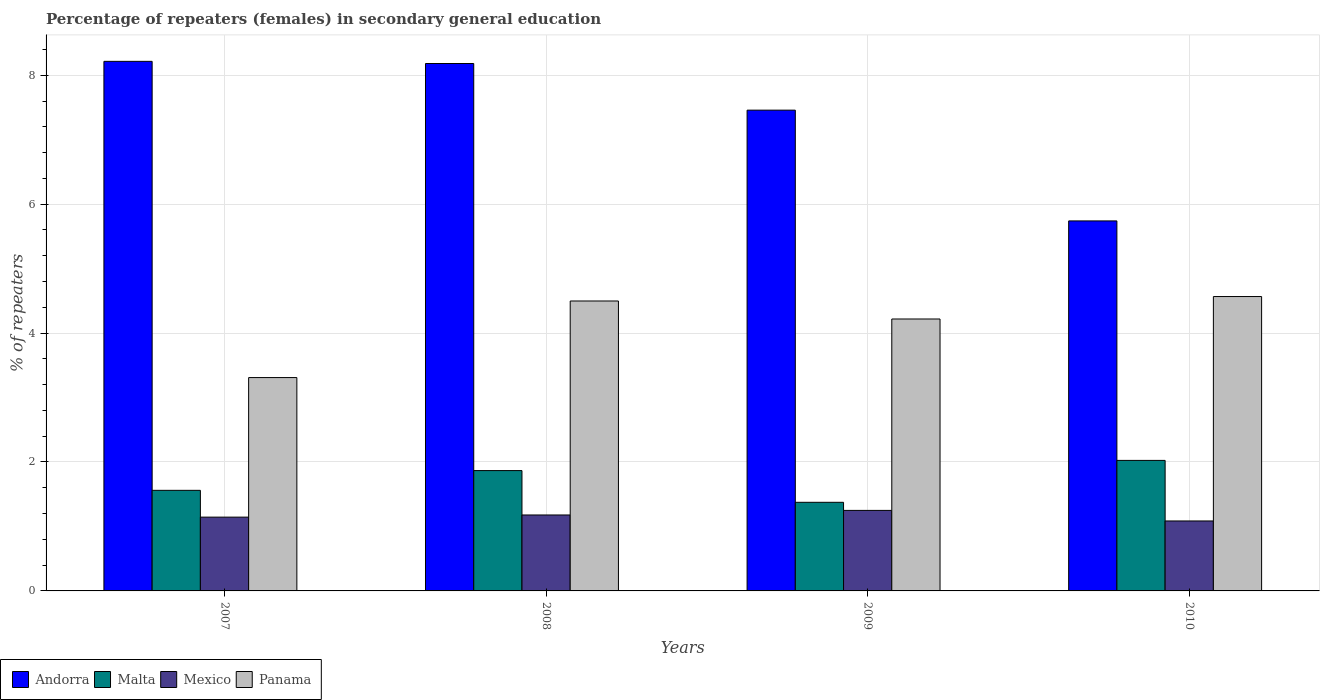How many different coloured bars are there?
Keep it short and to the point. 4. Are the number of bars per tick equal to the number of legend labels?
Your answer should be compact. Yes. In how many cases, is the number of bars for a given year not equal to the number of legend labels?
Your answer should be compact. 0. What is the percentage of female repeaters in Panama in 2007?
Offer a very short reply. 3.31. Across all years, what is the maximum percentage of female repeaters in Mexico?
Provide a short and direct response. 1.25. Across all years, what is the minimum percentage of female repeaters in Mexico?
Offer a very short reply. 1.09. In which year was the percentage of female repeaters in Malta maximum?
Provide a short and direct response. 2010. In which year was the percentage of female repeaters in Mexico minimum?
Your response must be concise. 2010. What is the total percentage of female repeaters in Andorra in the graph?
Provide a short and direct response. 29.6. What is the difference between the percentage of female repeaters in Andorra in 2008 and that in 2010?
Give a very brief answer. 2.44. What is the difference between the percentage of female repeaters in Andorra in 2007 and the percentage of female repeaters in Mexico in 2009?
Your answer should be very brief. 6.97. What is the average percentage of female repeaters in Andorra per year?
Offer a very short reply. 7.4. In the year 2010, what is the difference between the percentage of female repeaters in Malta and percentage of female repeaters in Panama?
Provide a short and direct response. -2.54. In how many years, is the percentage of female repeaters in Mexico greater than 2 %?
Your response must be concise. 0. What is the ratio of the percentage of female repeaters in Malta in 2007 to that in 2010?
Make the answer very short. 0.77. Is the percentage of female repeaters in Mexico in 2008 less than that in 2010?
Provide a succinct answer. No. Is the difference between the percentage of female repeaters in Malta in 2007 and 2008 greater than the difference between the percentage of female repeaters in Panama in 2007 and 2008?
Your answer should be compact. Yes. What is the difference between the highest and the second highest percentage of female repeaters in Malta?
Make the answer very short. 0.16. What is the difference between the highest and the lowest percentage of female repeaters in Panama?
Your response must be concise. 1.26. In how many years, is the percentage of female repeaters in Andorra greater than the average percentage of female repeaters in Andorra taken over all years?
Your response must be concise. 3. Is the sum of the percentage of female repeaters in Panama in 2008 and 2010 greater than the maximum percentage of female repeaters in Andorra across all years?
Keep it short and to the point. Yes. Is it the case that in every year, the sum of the percentage of female repeaters in Panama and percentage of female repeaters in Mexico is greater than the sum of percentage of female repeaters in Andorra and percentage of female repeaters in Malta?
Your response must be concise. No. What does the 3rd bar from the left in 2008 represents?
Provide a succinct answer. Mexico. What does the 3rd bar from the right in 2007 represents?
Your response must be concise. Malta. Is it the case that in every year, the sum of the percentage of female repeaters in Mexico and percentage of female repeaters in Malta is greater than the percentage of female repeaters in Panama?
Provide a succinct answer. No. How many bars are there?
Provide a short and direct response. 16. Are all the bars in the graph horizontal?
Offer a terse response. No. How many years are there in the graph?
Offer a terse response. 4. What is the difference between two consecutive major ticks on the Y-axis?
Provide a succinct answer. 2. Are the values on the major ticks of Y-axis written in scientific E-notation?
Offer a very short reply. No. Where does the legend appear in the graph?
Ensure brevity in your answer.  Bottom left. What is the title of the graph?
Offer a terse response. Percentage of repeaters (females) in secondary general education. What is the label or title of the X-axis?
Give a very brief answer. Years. What is the label or title of the Y-axis?
Your answer should be compact. % of repeaters. What is the % of repeaters of Andorra in 2007?
Offer a very short reply. 8.22. What is the % of repeaters in Malta in 2007?
Provide a short and direct response. 1.56. What is the % of repeaters in Mexico in 2007?
Provide a short and direct response. 1.14. What is the % of repeaters in Panama in 2007?
Keep it short and to the point. 3.31. What is the % of repeaters of Andorra in 2008?
Provide a short and direct response. 8.18. What is the % of repeaters of Malta in 2008?
Your response must be concise. 1.87. What is the % of repeaters in Mexico in 2008?
Provide a short and direct response. 1.18. What is the % of repeaters of Panama in 2008?
Your answer should be compact. 4.5. What is the % of repeaters of Andorra in 2009?
Keep it short and to the point. 7.46. What is the % of repeaters in Malta in 2009?
Offer a very short reply. 1.37. What is the % of repeaters of Mexico in 2009?
Make the answer very short. 1.25. What is the % of repeaters of Panama in 2009?
Give a very brief answer. 4.22. What is the % of repeaters in Andorra in 2010?
Provide a short and direct response. 5.74. What is the % of repeaters in Malta in 2010?
Your response must be concise. 2.02. What is the % of repeaters in Mexico in 2010?
Make the answer very short. 1.09. What is the % of repeaters in Panama in 2010?
Offer a terse response. 4.57. Across all years, what is the maximum % of repeaters of Andorra?
Offer a very short reply. 8.22. Across all years, what is the maximum % of repeaters in Malta?
Provide a short and direct response. 2.02. Across all years, what is the maximum % of repeaters of Mexico?
Provide a succinct answer. 1.25. Across all years, what is the maximum % of repeaters of Panama?
Provide a short and direct response. 4.57. Across all years, what is the minimum % of repeaters in Andorra?
Your response must be concise. 5.74. Across all years, what is the minimum % of repeaters in Malta?
Your response must be concise. 1.37. Across all years, what is the minimum % of repeaters of Mexico?
Your response must be concise. 1.09. Across all years, what is the minimum % of repeaters in Panama?
Provide a short and direct response. 3.31. What is the total % of repeaters in Andorra in the graph?
Provide a succinct answer. 29.6. What is the total % of repeaters in Malta in the graph?
Your answer should be compact. 6.83. What is the total % of repeaters in Mexico in the graph?
Your answer should be very brief. 4.66. What is the total % of repeaters of Panama in the graph?
Offer a very short reply. 16.59. What is the difference between the % of repeaters in Andorra in 2007 and that in 2008?
Ensure brevity in your answer.  0.03. What is the difference between the % of repeaters of Malta in 2007 and that in 2008?
Provide a succinct answer. -0.31. What is the difference between the % of repeaters of Mexico in 2007 and that in 2008?
Give a very brief answer. -0.03. What is the difference between the % of repeaters of Panama in 2007 and that in 2008?
Give a very brief answer. -1.19. What is the difference between the % of repeaters in Andorra in 2007 and that in 2009?
Provide a short and direct response. 0.76. What is the difference between the % of repeaters in Malta in 2007 and that in 2009?
Ensure brevity in your answer.  0.19. What is the difference between the % of repeaters in Mexico in 2007 and that in 2009?
Your answer should be compact. -0.1. What is the difference between the % of repeaters of Panama in 2007 and that in 2009?
Ensure brevity in your answer.  -0.91. What is the difference between the % of repeaters of Andorra in 2007 and that in 2010?
Your answer should be compact. 2.48. What is the difference between the % of repeaters in Malta in 2007 and that in 2010?
Make the answer very short. -0.46. What is the difference between the % of repeaters of Mexico in 2007 and that in 2010?
Give a very brief answer. 0.06. What is the difference between the % of repeaters of Panama in 2007 and that in 2010?
Provide a short and direct response. -1.26. What is the difference between the % of repeaters in Andorra in 2008 and that in 2009?
Offer a very short reply. 0.72. What is the difference between the % of repeaters in Malta in 2008 and that in 2009?
Keep it short and to the point. 0.49. What is the difference between the % of repeaters of Mexico in 2008 and that in 2009?
Your answer should be compact. -0.07. What is the difference between the % of repeaters in Panama in 2008 and that in 2009?
Ensure brevity in your answer.  0.28. What is the difference between the % of repeaters in Andorra in 2008 and that in 2010?
Your response must be concise. 2.44. What is the difference between the % of repeaters in Malta in 2008 and that in 2010?
Your answer should be compact. -0.16. What is the difference between the % of repeaters in Mexico in 2008 and that in 2010?
Offer a very short reply. 0.09. What is the difference between the % of repeaters in Panama in 2008 and that in 2010?
Provide a short and direct response. -0.07. What is the difference between the % of repeaters of Andorra in 2009 and that in 2010?
Your answer should be compact. 1.72. What is the difference between the % of repeaters of Malta in 2009 and that in 2010?
Make the answer very short. -0.65. What is the difference between the % of repeaters of Mexico in 2009 and that in 2010?
Your answer should be compact. 0.16. What is the difference between the % of repeaters of Panama in 2009 and that in 2010?
Your answer should be compact. -0.35. What is the difference between the % of repeaters in Andorra in 2007 and the % of repeaters in Malta in 2008?
Your answer should be very brief. 6.35. What is the difference between the % of repeaters in Andorra in 2007 and the % of repeaters in Mexico in 2008?
Provide a short and direct response. 7.04. What is the difference between the % of repeaters of Andorra in 2007 and the % of repeaters of Panama in 2008?
Give a very brief answer. 3.72. What is the difference between the % of repeaters of Malta in 2007 and the % of repeaters of Mexico in 2008?
Make the answer very short. 0.38. What is the difference between the % of repeaters in Malta in 2007 and the % of repeaters in Panama in 2008?
Keep it short and to the point. -2.94. What is the difference between the % of repeaters of Mexico in 2007 and the % of repeaters of Panama in 2008?
Keep it short and to the point. -3.35. What is the difference between the % of repeaters in Andorra in 2007 and the % of repeaters in Malta in 2009?
Ensure brevity in your answer.  6.84. What is the difference between the % of repeaters of Andorra in 2007 and the % of repeaters of Mexico in 2009?
Provide a succinct answer. 6.97. What is the difference between the % of repeaters in Andorra in 2007 and the % of repeaters in Panama in 2009?
Offer a terse response. 4. What is the difference between the % of repeaters of Malta in 2007 and the % of repeaters of Mexico in 2009?
Offer a very short reply. 0.31. What is the difference between the % of repeaters in Malta in 2007 and the % of repeaters in Panama in 2009?
Provide a short and direct response. -2.66. What is the difference between the % of repeaters in Mexico in 2007 and the % of repeaters in Panama in 2009?
Offer a terse response. -3.07. What is the difference between the % of repeaters of Andorra in 2007 and the % of repeaters of Malta in 2010?
Your answer should be compact. 6.19. What is the difference between the % of repeaters in Andorra in 2007 and the % of repeaters in Mexico in 2010?
Offer a very short reply. 7.13. What is the difference between the % of repeaters of Andorra in 2007 and the % of repeaters of Panama in 2010?
Give a very brief answer. 3.65. What is the difference between the % of repeaters of Malta in 2007 and the % of repeaters of Mexico in 2010?
Make the answer very short. 0.48. What is the difference between the % of repeaters of Malta in 2007 and the % of repeaters of Panama in 2010?
Offer a terse response. -3.01. What is the difference between the % of repeaters in Mexico in 2007 and the % of repeaters in Panama in 2010?
Give a very brief answer. -3.42. What is the difference between the % of repeaters in Andorra in 2008 and the % of repeaters in Malta in 2009?
Your answer should be very brief. 6.81. What is the difference between the % of repeaters in Andorra in 2008 and the % of repeaters in Mexico in 2009?
Offer a terse response. 6.93. What is the difference between the % of repeaters of Andorra in 2008 and the % of repeaters of Panama in 2009?
Provide a succinct answer. 3.96. What is the difference between the % of repeaters of Malta in 2008 and the % of repeaters of Mexico in 2009?
Offer a terse response. 0.62. What is the difference between the % of repeaters of Malta in 2008 and the % of repeaters of Panama in 2009?
Provide a short and direct response. -2.35. What is the difference between the % of repeaters in Mexico in 2008 and the % of repeaters in Panama in 2009?
Your answer should be very brief. -3.04. What is the difference between the % of repeaters of Andorra in 2008 and the % of repeaters of Malta in 2010?
Keep it short and to the point. 6.16. What is the difference between the % of repeaters of Andorra in 2008 and the % of repeaters of Mexico in 2010?
Provide a succinct answer. 7.1. What is the difference between the % of repeaters in Andorra in 2008 and the % of repeaters in Panama in 2010?
Keep it short and to the point. 3.61. What is the difference between the % of repeaters of Malta in 2008 and the % of repeaters of Mexico in 2010?
Provide a succinct answer. 0.78. What is the difference between the % of repeaters in Malta in 2008 and the % of repeaters in Panama in 2010?
Make the answer very short. -2.7. What is the difference between the % of repeaters of Mexico in 2008 and the % of repeaters of Panama in 2010?
Your response must be concise. -3.39. What is the difference between the % of repeaters in Andorra in 2009 and the % of repeaters in Malta in 2010?
Your response must be concise. 5.43. What is the difference between the % of repeaters of Andorra in 2009 and the % of repeaters of Mexico in 2010?
Your answer should be very brief. 6.37. What is the difference between the % of repeaters of Andorra in 2009 and the % of repeaters of Panama in 2010?
Keep it short and to the point. 2.89. What is the difference between the % of repeaters in Malta in 2009 and the % of repeaters in Mexico in 2010?
Your answer should be compact. 0.29. What is the difference between the % of repeaters in Malta in 2009 and the % of repeaters in Panama in 2010?
Your response must be concise. -3.19. What is the difference between the % of repeaters in Mexico in 2009 and the % of repeaters in Panama in 2010?
Your answer should be very brief. -3.32. What is the average % of repeaters of Andorra per year?
Your answer should be very brief. 7.4. What is the average % of repeaters in Malta per year?
Provide a short and direct response. 1.71. What is the average % of repeaters in Mexico per year?
Provide a short and direct response. 1.16. What is the average % of repeaters of Panama per year?
Offer a very short reply. 4.15. In the year 2007, what is the difference between the % of repeaters of Andorra and % of repeaters of Malta?
Provide a succinct answer. 6.65. In the year 2007, what is the difference between the % of repeaters of Andorra and % of repeaters of Mexico?
Give a very brief answer. 7.07. In the year 2007, what is the difference between the % of repeaters of Andorra and % of repeaters of Panama?
Give a very brief answer. 4.91. In the year 2007, what is the difference between the % of repeaters of Malta and % of repeaters of Mexico?
Your answer should be very brief. 0.42. In the year 2007, what is the difference between the % of repeaters in Malta and % of repeaters in Panama?
Your response must be concise. -1.75. In the year 2007, what is the difference between the % of repeaters in Mexico and % of repeaters in Panama?
Your answer should be very brief. -2.17. In the year 2008, what is the difference between the % of repeaters in Andorra and % of repeaters in Malta?
Your response must be concise. 6.32. In the year 2008, what is the difference between the % of repeaters of Andorra and % of repeaters of Mexico?
Provide a succinct answer. 7. In the year 2008, what is the difference between the % of repeaters in Andorra and % of repeaters in Panama?
Provide a short and direct response. 3.68. In the year 2008, what is the difference between the % of repeaters in Malta and % of repeaters in Mexico?
Ensure brevity in your answer.  0.69. In the year 2008, what is the difference between the % of repeaters in Malta and % of repeaters in Panama?
Ensure brevity in your answer.  -2.63. In the year 2008, what is the difference between the % of repeaters of Mexico and % of repeaters of Panama?
Ensure brevity in your answer.  -3.32. In the year 2009, what is the difference between the % of repeaters in Andorra and % of repeaters in Malta?
Make the answer very short. 6.08. In the year 2009, what is the difference between the % of repeaters in Andorra and % of repeaters in Mexico?
Your response must be concise. 6.21. In the year 2009, what is the difference between the % of repeaters of Andorra and % of repeaters of Panama?
Keep it short and to the point. 3.24. In the year 2009, what is the difference between the % of repeaters of Malta and % of repeaters of Mexico?
Give a very brief answer. 0.13. In the year 2009, what is the difference between the % of repeaters of Malta and % of repeaters of Panama?
Ensure brevity in your answer.  -2.84. In the year 2009, what is the difference between the % of repeaters in Mexico and % of repeaters in Panama?
Keep it short and to the point. -2.97. In the year 2010, what is the difference between the % of repeaters of Andorra and % of repeaters of Malta?
Your answer should be compact. 3.72. In the year 2010, what is the difference between the % of repeaters in Andorra and % of repeaters in Mexico?
Give a very brief answer. 4.65. In the year 2010, what is the difference between the % of repeaters in Andorra and % of repeaters in Panama?
Make the answer very short. 1.17. In the year 2010, what is the difference between the % of repeaters in Malta and % of repeaters in Mexico?
Offer a terse response. 0.94. In the year 2010, what is the difference between the % of repeaters in Malta and % of repeaters in Panama?
Make the answer very short. -2.54. In the year 2010, what is the difference between the % of repeaters of Mexico and % of repeaters of Panama?
Offer a terse response. -3.48. What is the ratio of the % of repeaters of Andorra in 2007 to that in 2008?
Give a very brief answer. 1. What is the ratio of the % of repeaters of Malta in 2007 to that in 2008?
Your answer should be compact. 0.84. What is the ratio of the % of repeaters of Mexico in 2007 to that in 2008?
Give a very brief answer. 0.97. What is the ratio of the % of repeaters in Panama in 2007 to that in 2008?
Your answer should be compact. 0.74. What is the ratio of the % of repeaters in Andorra in 2007 to that in 2009?
Provide a short and direct response. 1.1. What is the ratio of the % of repeaters in Malta in 2007 to that in 2009?
Your answer should be compact. 1.14. What is the ratio of the % of repeaters in Mexico in 2007 to that in 2009?
Your answer should be very brief. 0.92. What is the ratio of the % of repeaters of Panama in 2007 to that in 2009?
Your answer should be very brief. 0.78. What is the ratio of the % of repeaters in Andorra in 2007 to that in 2010?
Offer a very short reply. 1.43. What is the ratio of the % of repeaters in Malta in 2007 to that in 2010?
Offer a terse response. 0.77. What is the ratio of the % of repeaters in Mexico in 2007 to that in 2010?
Keep it short and to the point. 1.05. What is the ratio of the % of repeaters of Panama in 2007 to that in 2010?
Your response must be concise. 0.72. What is the ratio of the % of repeaters of Andorra in 2008 to that in 2009?
Make the answer very short. 1.1. What is the ratio of the % of repeaters of Malta in 2008 to that in 2009?
Make the answer very short. 1.36. What is the ratio of the % of repeaters in Mexico in 2008 to that in 2009?
Your response must be concise. 0.94. What is the ratio of the % of repeaters of Panama in 2008 to that in 2009?
Keep it short and to the point. 1.07. What is the ratio of the % of repeaters in Andorra in 2008 to that in 2010?
Make the answer very short. 1.43. What is the ratio of the % of repeaters in Malta in 2008 to that in 2010?
Offer a very short reply. 0.92. What is the ratio of the % of repeaters in Mexico in 2008 to that in 2010?
Provide a succinct answer. 1.09. What is the ratio of the % of repeaters of Panama in 2008 to that in 2010?
Give a very brief answer. 0.98. What is the ratio of the % of repeaters of Andorra in 2009 to that in 2010?
Your answer should be very brief. 1.3. What is the ratio of the % of repeaters of Malta in 2009 to that in 2010?
Offer a terse response. 0.68. What is the ratio of the % of repeaters of Mexico in 2009 to that in 2010?
Make the answer very short. 1.15. What is the ratio of the % of repeaters of Panama in 2009 to that in 2010?
Your answer should be compact. 0.92. What is the difference between the highest and the second highest % of repeaters in Andorra?
Provide a succinct answer. 0.03. What is the difference between the highest and the second highest % of repeaters of Malta?
Provide a succinct answer. 0.16. What is the difference between the highest and the second highest % of repeaters of Mexico?
Keep it short and to the point. 0.07. What is the difference between the highest and the second highest % of repeaters in Panama?
Offer a very short reply. 0.07. What is the difference between the highest and the lowest % of repeaters of Andorra?
Ensure brevity in your answer.  2.48. What is the difference between the highest and the lowest % of repeaters of Malta?
Your answer should be compact. 0.65. What is the difference between the highest and the lowest % of repeaters in Mexico?
Provide a succinct answer. 0.16. What is the difference between the highest and the lowest % of repeaters of Panama?
Your response must be concise. 1.26. 